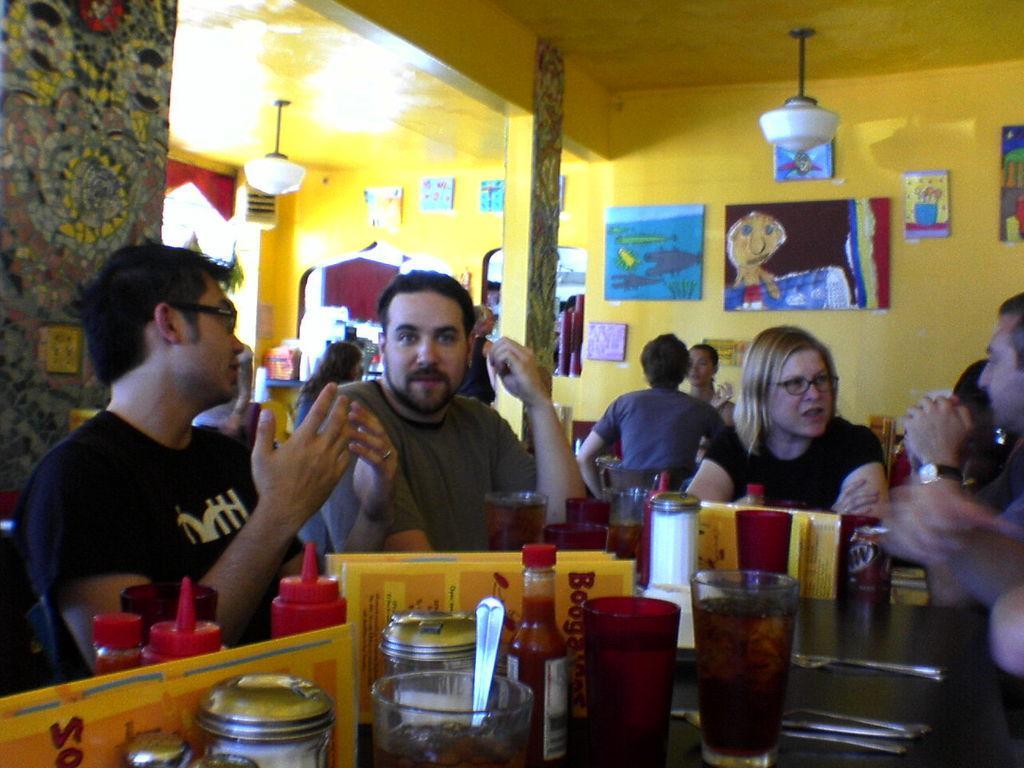In one or two sentences, can you explain what this image depicts? In this image we can see a group of people siting beside a table containing some boards, glasses, spoons, a tin, knives and some objects on it. We can also see pillars, some people sitting, at window, frames on a wall and a roof with some ceiling lights. 